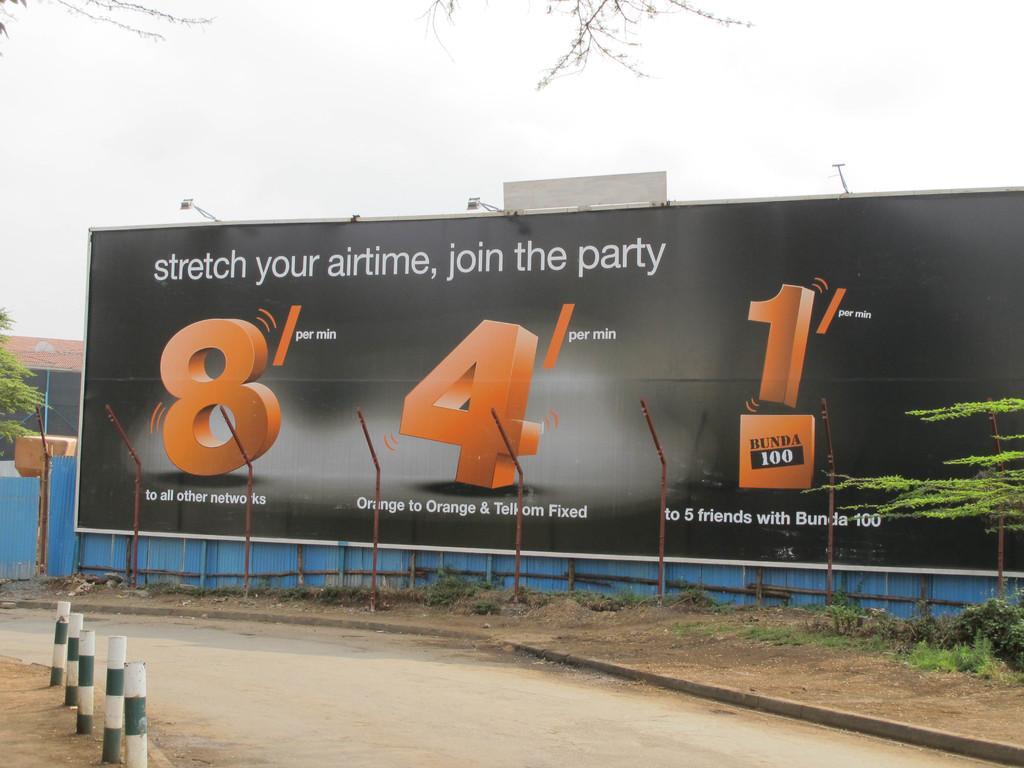Describe this image in one or two sentences. In the picture there is an advertisement board attached in front of a fencing and there are few poles beside the road in front of that board, on the right side there is a plant. 